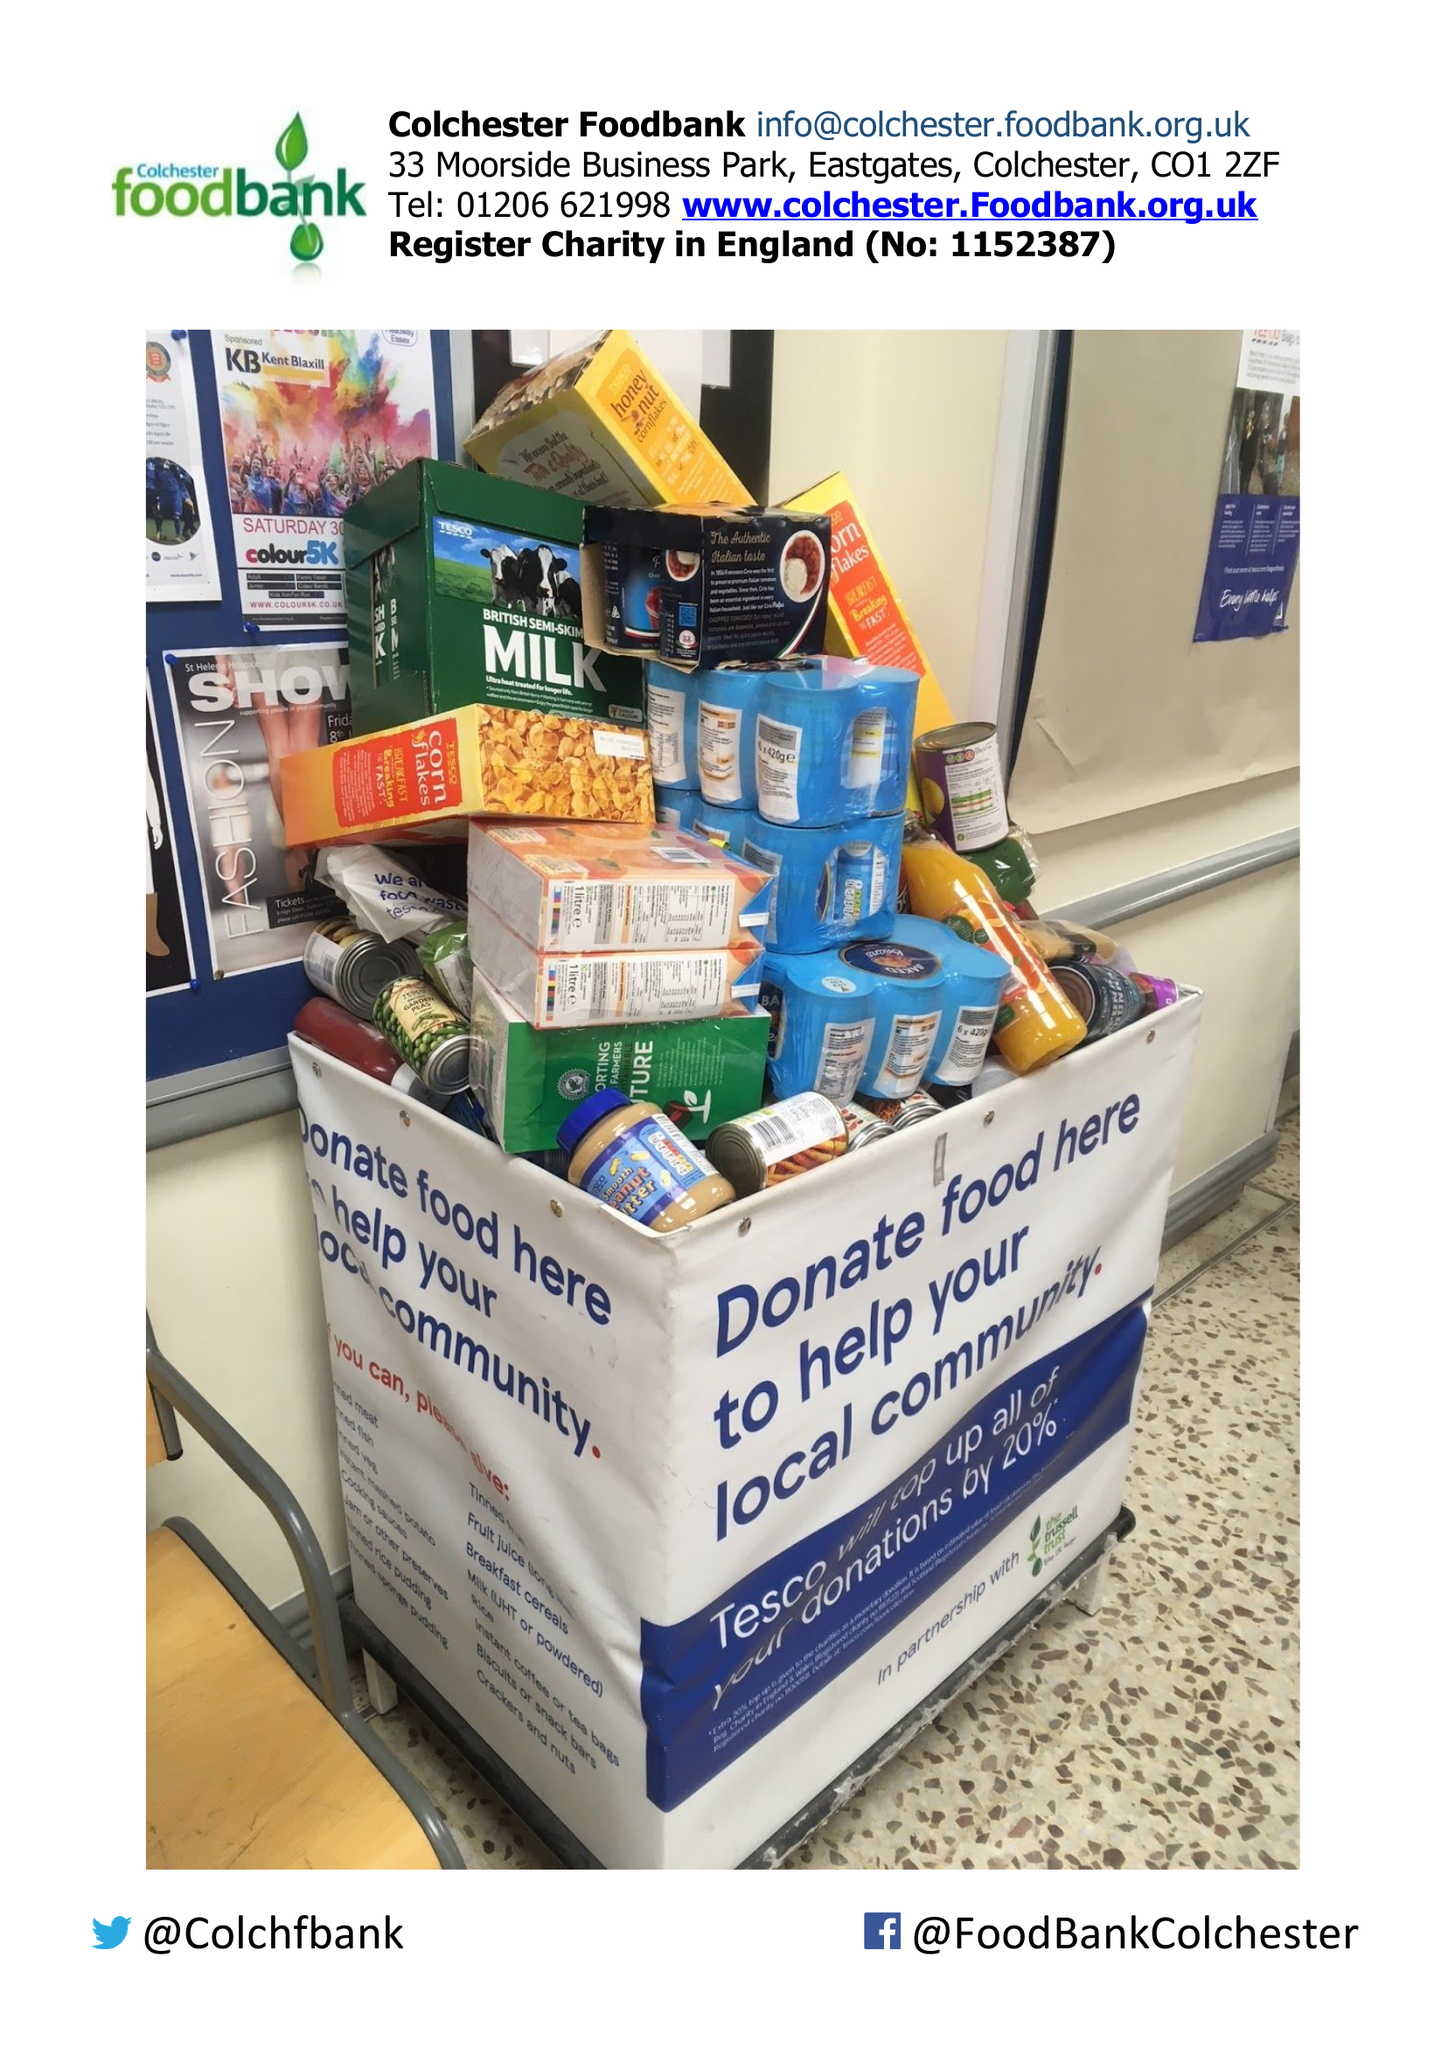What is the value for the spending_annually_in_british_pounds?
Answer the question using a single word or phrase. 36073.00 